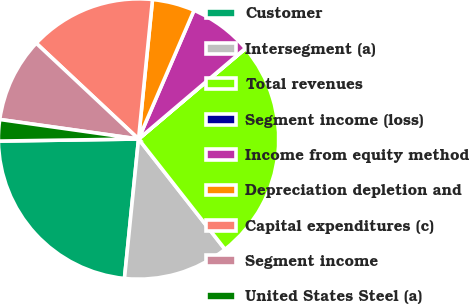Convert chart to OTSL. <chart><loc_0><loc_0><loc_500><loc_500><pie_chart><fcel>Customer<fcel>Intersegment (a)<fcel>Total revenues<fcel>Segment income (loss)<fcel>Income from equity method<fcel>Depreciation depletion and<fcel>Capital expenditures (c)<fcel>Segment income<fcel>United States Steel (a)<nl><fcel>23.16%<fcel>12.18%<fcel>25.59%<fcel>0.03%<fcel>7.32%<fcel>4.89%<fcel>14.61%<fcel>9.75%<fcel>2.46%<nl></chart> 